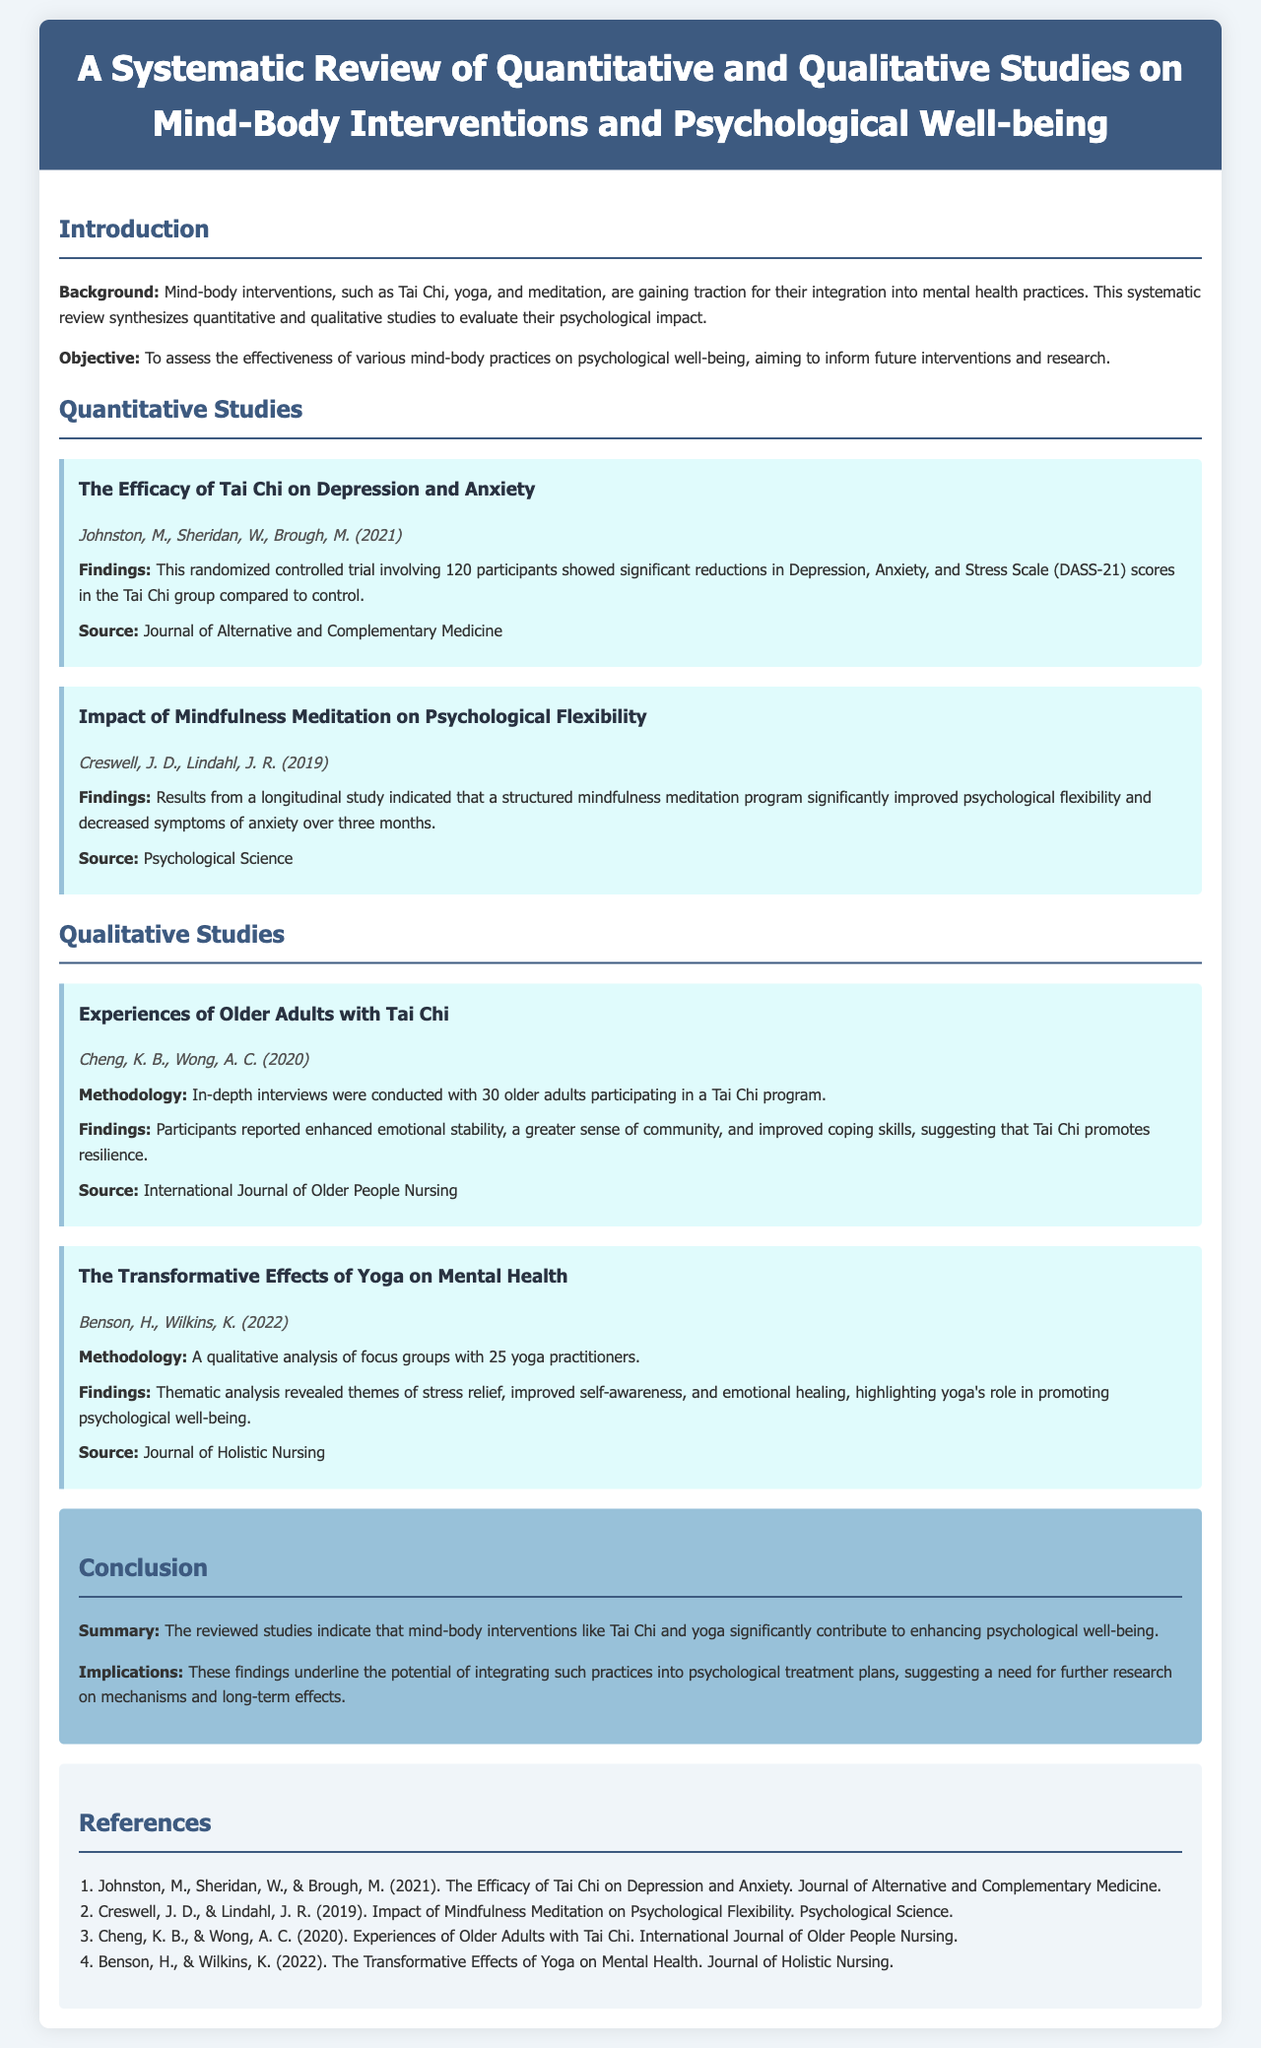What is the primary focus of this systematic review? The review synthesizes quantitative and qualitative studies to evaluate the psychological impact of mind-body interventions.
Answer: Psychological impact of mind-body interventions Who conducted the study on the efficacy of Tai Chi? The authors of the study are noted in the section on quantitative studies.
Answer: Johnston, M., Sheridan, W., Brough, M How many participants were involved in the Tai Chi study? The document specifies the number of participants in the trial.
Answer: 120 What was a significant finding from the mindfulness meditation study? The findings indicate improvements in psychological flexibility and decreased symptoms of anxiety.
Answer: Improved psychological flexibility Which mind-body practice was highlighted in the qualitative study about older adults? The qualitative study discusses a specific practice among older adult participants.
Answer: Tai Chi What was the sample size of the qualitative study on yoga's effects? The document provides the number of yoga practitioners involved in the qualitative analysis.
Answer: 25 How did participants of Tai Chi report their emotional state? The findings from the interviews illustrate how participants felt regarding their emotional well-being.
Answer: Enhanced emotional stability What is a recommended integration based on the findings? The conclusion notes the potential of certain practices to be used in specific contexts.
Answer: Psychological treatment plans What does the systematic review suggest about the need for further research? The conclusion emphasizes a specific area for future inquiry.
Answer: Mechanisms and long-term effects 